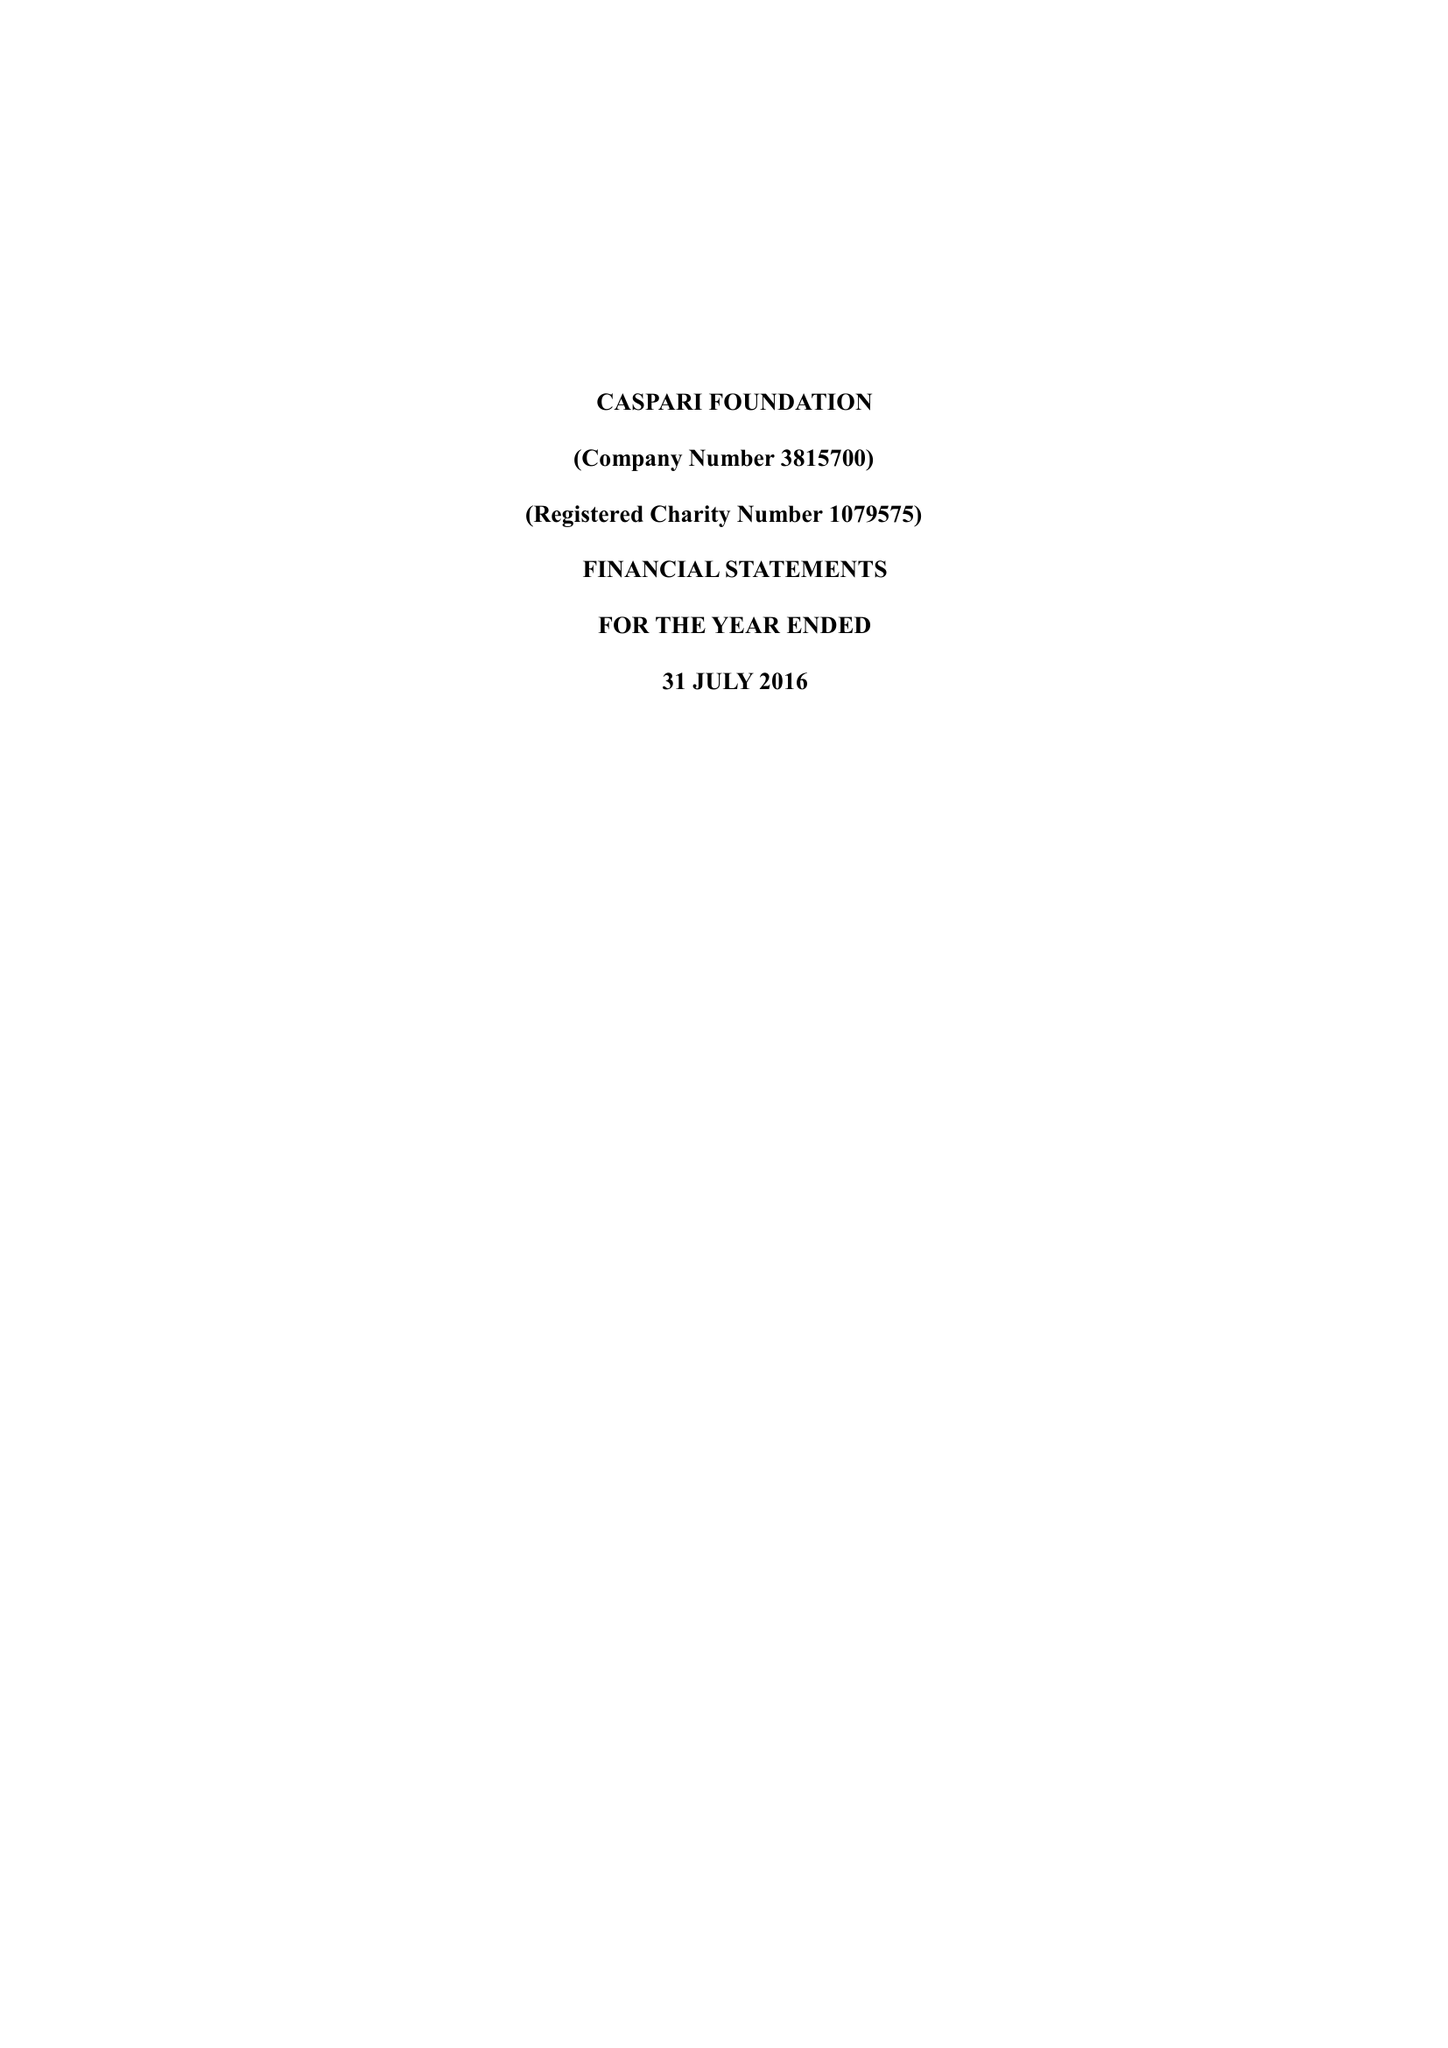What is the value for the charity_number?
Answer the question using a single word or phrase. 1079575 